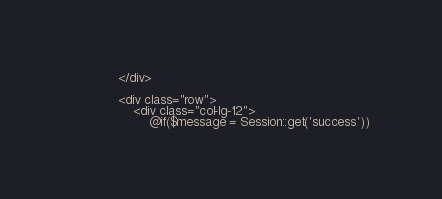Convert code to text. <code><loc_0><loc_0><loc_500><loc_500><_PHP_>            </div>

            <div class="row">
                <div class="col-lg-12">
                    @if($message = Session::get('success'))</code> 